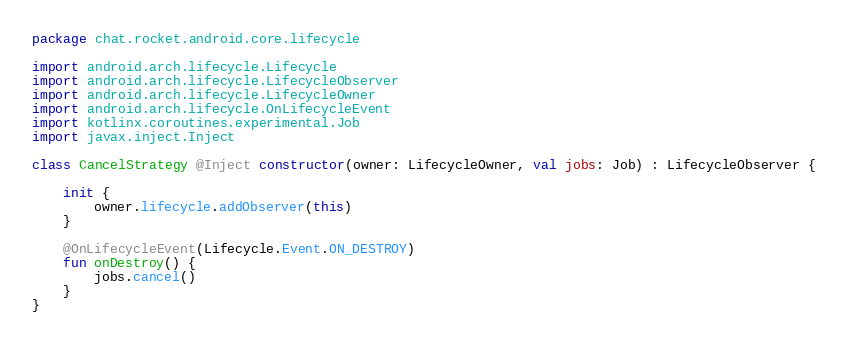<code> <loc_0><loc_0><loc_500><loc_500><_Kotlin_>package chat.rocket.android.core.lifecycle

import android.arch.lifecycle.Lifecycle
import android.arch.lifecycle.LifecycleObserver
import android.arch.lifecycle.LifecycleOwner
import android.arch.lifecycle.OnLifecycleEvent
import kotlinx.coroutines.experimental.Job
import javax.inject.Inject

class CancelStrategy @Inject constructor(owner: LifecycleOwner, val jobs: Job) : LifecycleObserver {

    init {
        owner.lifecycle.addObserver(this)
    }

    @OnLifecycleEvent(Lifecycle.Event.ON_DESTROY)
    fun onDestroy() {
        jobs.cancel()
    }
}</code> 